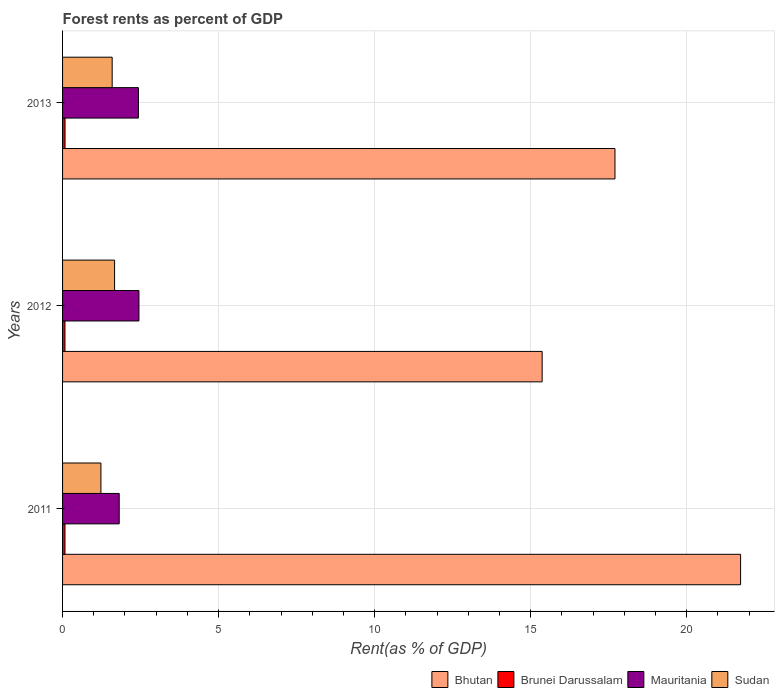How many different coloured bars are there?
Offer a very short reply. 4. Are the number of bars per tick equal to the number of legend labels?
Ensure brevity in your answer.  Yes. How many bars are there on the 1st tick from the top?
Your response must be concise. 4. How many bars are there on the 1st tick from the bottom?
Provide a succinct answer. 4. What is the forest rent in Mauritania in 2013?
Offer a very short reply. 2.43. Across all years, what is the maximum forest rent in Bhutan?
Offer a very short reply. 21.73. Across all years, what is the minimum forest rent in Sudan?
Your answer should be compact. 1.23. What is the total forest rent in Sudan in the graph?
Provide a short and direct response. 4.49. What is the difference between the forest rent in Mauritania in 2011 and that in 2013?
Give a very brief answer. -0.62. What is the difference between the forest rent in Mauritania in 2011 and the forest rent in Brunei Darussalam in 2013?
Make the answer very short. 1.74. What is the average forest rent in Bhutan per year?
Offer a terse response. 18.26. In the year 2012, what is the difference between the forest rent in Sudan and forest rent in Mauritania?
Keep it short and to the point. -0.78. In how many years, is the forest rent in Bhutan greater than 10 %?
Provide a succinct answer. 3. What is the ratio of the forest rent in Sudan in 2011 to that in 2012?
Offer a terse response. 0.74. Is the forest rent in Bhutan in 2011 less than that in 2012?
Provide a short and direct response. No. What is the difference between the highest and the second highest forest rent in Sudan?
Ensure brevity in your answer.  0.08. What is the difference between the highest and the lowest forest rent in Brunei Darussalam?
Provide a succinct answer. 0. In how many years, is the forest rent in Sudan greater than the average forest rent in Sudan taken over all years?
Your response must be concise. 2. What does the 4th bar from the top in 2013 represents?
Offer a very short reply. Bhutan. What does the 2nd bar from the bottom in 2013 represents?
Offer a very short reply. Brunei Darussalam. How many bars are there?
Your response must be concise. 12. How many years are there in the graph?
Give a very brief answer. 3. What is the difference between two consecutive major ticks on the X-axis?
Provide a short and direct response. 5. Does the graph contain any zero values?
Offer a terse response. No. Where does the legend appear in the graph?
Provide a short and direct response. Bottom right. How many legend labels are there?
Your answer should be very brief. 4. How are the legend labels stacked?
Keep it short and to the point. Horizontal. What is the title of the graph?
Your answer should be very brief. Forest rents as percent of GDP. What is the label or title of the X-axis?
Offer a very short reply. Rent(as % of GDP). What is the label or title of the Y-axis?
Offer a terse response. Years. What is the Rent(as % of GDP) in Bhutan in 2011?
Ensure brevity in your answer.  21.73. What is the Rent(as % of GDP) in Brunei Darussalam in 2011?
Your response must be concise. 0.08. What is the Rent(as % of GDP) of Mauritania in 2011?
Your response must be concise. 1.82. What is the Rent(as % of GDP) in Sudan in 2011?
Keep it short and to the point. 1.23. What is the Rent(as % of GDP) of Bhutan in 2012?
Your answer should be compact. 15.37. What is the Rent(as % of GDP) of Brunei Darussalam in 2012?
Offer a terse response. 0.08. What is the Rent(as % of GDP) in Mauritania in 2012?
Ensure brevity in your answer.  2.45. What is the Rent(as % of GDP) in Sudan in 2012?
Your response must be concise. 1.67. What is the Rent(as % of GDP) in Bhutan in 2013?
Offer a very short reply. 17.7. What is the Rent(as % of GDP) in Brunei Darussalam in 2013?
Your answer should be compact. 0.08. What is the Rent(as % of GDP) of Mauritania in 2013?
Provide a short and direct response. 2.43. What is the Rent(as % of GDP) in Sudan in 2013?
Provide a short and direct response. 1.59. Across all years, what is the maximum Rent(as % of GDP) in Bhutan?
Your response must be concise. 21.73. Across all years, what is the maximum Rent(as % of GDP) of Brunei Darussalam?
Offer a very short reply. 0.08. Across all years, what is the maximum Rent(as % of GDP) of Mauritania?
Your answer should be very brief. 2.45. Across all years, what is the maximum Rent(as % of GDP) in Sudan?
Offer a terse response. 1.67. Across all years, what is the minimum Rent(as % of GDP) in Bhutan?
Provide a succinct answer. 15.37. Across all years, what is the minimum Rent(as % of GDP) of Brunei Darussalam?
Make the answer very short. 0.08. Across all years, what is the minimum Rent(as % of GDP) in Mauritania?
Offer a very short reply. 1.82. Across all years, what is the minimum Rent(as % of GDP) in Sudan?
Your answer should be compact. 1.23. What is the total Rent(as % of GDP) of Bhutan in the graph?
Give a very brief answer. 54.79. What is the total Rent(as % of GDP) in Brunei Darussalam in the graph?
Provide a succinct answer. 0.23. What is the total Rent(as % of GDP) in Mauritania in the graph?
Provide a succinct answer. 6.69. What is the total Rent(as % of GDP) in Sudan in the graph?
Your answer should be very brief. 4.49. What is the difference between the Rent(as % of GDP) in Bhutan in 2011 and that in 2012?
Your answer should be compact. 6.36. What is the difference between the Rent(as % of GDP) of Brunei Darussalam in 2011 and that in 2012?
Provide a short and direct response. 0. What is the difference between the Rent(as % of GDP) of Mauritania in 2011 and that in 2012?
Ensure brevity in your answer.  -0.63. What is the difference between the Rent(as % of GDP) of Sudan in 2011 and that in 2012?
Make the answer very short. -0.44. What is the difference between the Rent(as % of GDP) in Bhutan in 2011 and that in 2013?
Your answer should be compact. 4.03. What is the difference between the Rent(as % of GDP) of Brunei Darussalam in 2011 and that in 2013?
Offer a terse response. -0. What is the difference between the Rent(as % of GDP) in Mauritania in 2011 and that in 2013?
Keep it short and to the point. -0.62. What is the difference between the Rent(as % of GDP) of Sudan in 2011 and that in 2013?
Make the answer very short. -0.36. What is the difference between the Rent(as % of GDP) in Bhutan in 2012 and that in 2013?
Your answer should be very brief. -2.33. What is the difference between the Rent(as % of GDP) of Brunei Darussalam in 2012 and that in 2013?
Give a very brief answer. -0. What is the difference between the Rent(as % of GDP) of Mauritania in 2012 and that in 2013?
Keep it short and to the point. 0.02. What is the difference between the Rent(as % of GDP) of Sudan in 2012 and that in 2013?
Your answer should be compact. 0.08. What is the difference between the Rent(as % of GDP) in Bhutan in 2011 and the Rent(as % of GDP) in Brunei Darussalam in 2012?
Offer a very short reply. 21.65. What is the difference between the Rent(as % of GDP) of Bhutan in 2011 and the Rent(as % of GDP) of Mauritania in 2012?
Make the answer very short. 19.28. What is the difference between the Rent(as % of GDP) in Bhutan in 2011 and the Rent(as % of GDP) in Sudan in 2012?
Your answer should be very brief. 20.06. What is the difference between the Rent(as % of GDP) in Brunei Darussalam in 2011 and the Rent(as % of GDP) in Mauritania in 2012?
Give a very brief answer. -2.37. What is the difference between the Rent(as % of GDP) in Brunei Darussalam in 2011 and the Rent(as % of GDP) in Sudan in 2012?
Your answer should be compact. -1.59. What is the difference between the Rent(as % of GDP) of Mauritania in 2011 and the Rent(as % of GDP) of Sudan in 2012?
Your response must be concise. 0.15. What is the difference between the Rent(as % of GDP) in Bhutan in 2011 and the Rent(as % of GDP) in Brunei Darussalam in 2013?
Give a very brief answer. 21.65. What is the difference between the Rent(as % of GDP) in Bhutan in 2011 and the Rent(as % of GDP) in Mauritania in 2013?
Your answer should be compact. 19.3. What is the difference between the Rent(as % of GDP) of Bhutan in 2011 and the Rent(as % of GDP) of Sudan in 2013?
Ensure brevity in your answer.  20.14. What is the difference between the Rent(as % of GDP) of Brunei Darussalam in 2011 and the Rent(as % of GDP) of Mauritania in 2013?
Provide a short and direct response. -2.35. What is the difference between the Rent(as % of GDP) in Brunei Darussalam in 2011 and the Rent(as % of GDP) in Sudan in 2013?
Your answer should be very brief. -1.51. What is the difference between the Rent(as % of GDP) of Mauritania in 2011 and the Rent(as % of GDP) of Sudan in 2013?
Your answer should be very brief. 0.23. What is the difference between the Rent(as % of GDP) of Bhutan in 2012 and the Rent(as % of GDP) of Brunei Darussalam in 2013?
Provide a short and direct response. 15.29. What is the difference between the Rent(as % of GDP) of Bhutan in 2012 and the Rent(as % of GDP) of Mauritania in 2013?
Provide a short and direct response. 12.94. What is the difference between the Rent(as % of GDP) in Bhutan in 2012 and the Rent(as % of GDP) in Sudan in 2013?
Your answer should be compact. 13.78. What is the difference between the Rent(as % of GDP) in Brunei Darussalam in 2012 and the Rent(as % of GDP) in Mauritania in 2013?
Make the answer very short. -2.35. What is the difference between the Rent(as % of GDP) in Brunei Darussalam in 2012 and the Rent(as % of GDP) in Sudan in 2013?
Your answer should be compact. -1.51. What is the difference between the Rent(as % of GDP) of Mauritania in 2012 and the Rent(as % of GDP) of Sudan in 2013?
Make the answer very short. 0.86. What is the average Rent(as % of GDP) of Bhutan per year?
Make the answer very short. 18.26. What is the average Rent(as % of GDP) in Brunei Darussalam per year?
Your response must be concise. 0.08. What is the average Rent(as % of GDP) in Mauritania per year?
Give a very brief answer. 2.23. What is the average Rent(as % of GDP) in Sudan per year?
Offer a very short reply. 1.5. In the year 2011, what is the difference between the Rent(as % of GDP) in Bhutan and Rent(as % of GDP) in Brunei Darussalam?
Offer a terse response. 21.65. In the year 2011, what is the difference between the Rent(as % of GDP) in Bhutan and Rent(as % of GDP) in Mauritania?
Your response must be concise. 19.91. In the year 2011, what is the difference between the Rent(as % of GDP) in Bhutan and Rent(as % of GDP) in Sudan?
Keep it short and to the point. 20.5. In the year 2011, what is the difference between the Rent(as % of GDP) of Brunei Darussalam and Rent(as % of GDP) of Mauritania?
Ensure brevity in your answer.  -1.74. In the year 2011, what is the difference between the Rent(as % of GDP) in Brunei Darussalam and Rent(as % of GDP) in Sudan?
Give a very brief answer. -1.15. In the year 2011, what is the difference between the Rent(as % of GDP) in Mauritania and Rent(as % of GDP) in Sudan?
Offer a terse response. 0.59. In the year 2012, what is the difference between the Rent(as % of GDP) in Bhutan and Rent(as % of GDP) in Brunei Darussalam?
Keep it short and to the point. 15.29. In the year 2012, what is the difference between the Rent(as % of GDP) of Bhutan and Rent(as % of GDP) of Mauritania?
Provide a short and direct response. 12.92. In the year 2012, what is the difference between the Rent(as % of GDP) of Bhutan and Rent(as % of GDP) of Sudan?
Ensure brevity in your answer.  13.7. In the year 2012, what is the difference between the Rent(as % of GDP) of Brunei Darussalam and Rent(as % of GDP) of Mauritania?
Ensure brevity in your answer.  -2.37. In the year 2012, what is the difference between the Rent(as % of GDP) of Brunei Darussalam and Rent(as % of GDP) of Sudan?
Make the answer very short. -1.59. In the year 2012, what is the difference between the Rent(as % of GDP) in Mauritania and Rent(as % of GDP) in Sudan?
Give a very brief answer. 0.78. In the year 2013, what is the difference between the Rent(as % of GDP) in Bhutan and Rent(as % of GDP) in Brunei Darussalam?
Provide a succinct answer. 17.62. In the year 2013, what is the difference between the Rent(as % of GDP) of Bhutan and Rent(as % of GDP) of Mauritania?
Your response must be concise. 15.27. In the year 2013, what is the difference between the Rent(as % of GDP) of Bhutan and Rent(as % of GDP) of Sudan?
Give a very brief answer. 16.11. In the year 2013, what is the difference between the Rent(as % of GDP) in Brunei Darussalam and Rent(as % of GDP) in Mauritania?
Your response must be concise. -2.35. In the year 2013, what is the difference between the Rent(as % of GDP) of Brunei Darussalam and Rent(as % of GDP) of Sudan?
Make the answer very short. -1.51. In the year 2013, what is the difference between the Rent(as % of GDP) of Mauritania and Rent(as % of GDP) of Sudan?
Ensure brevity in your answer.  0.84. What is the ratio of the Rent(as % of GDP) of Bhutan in 2011 to that in 2012?
Keep it short and to the point. 1.41. What is the ratio of the Rent(as % of GDP) in Mauritania in 2011 to that in 2012?
Your response must be concise. 0.74. What is the ratio of the Rent(as % of GDP) of Sudan in 2011 to that in 2012?
Your answer should be compact. 0.74. What is the ratio of the Rent(as % of GDP) of Bhutan in 2011 to that in 2013?
Your response must be concise. 1.23. What is the ratio of the Rent(as % of GDP) in Brunei Darussalam in 2011 to that in 2013?
Provide a succinct answer. 0.98. What is the ratio of the Rent(as % of GDP) of Mauritania in 2011 to that in 2013?
Give a very brief answer. 0.75. What is the ratio of the Rent(as % of GDP) of Sudan in 2011 to that in 2013?
Offer a terse response. 0.77. What is the ratio of the Rent(as % of GDP) in Bhutan in 2012 to that in 2013?
Provide a short and direct response. 0.87. What is the ratio of the Rent(as % of GDP) in Brunei Darussalam in 2012 to that in 2013?
Ensure brevity in your answer.  0.97. What is the ratio of the Rent(as % of GDP) of Mauritania in 2012 to that in 2013?
Provide a short and direct response. 1.01. What is the ratio of the Rent(as % of GDP) of Sudan in 2012 to that in 2013?
Offer a very short reply. 1.05. What is the difference between the highest and the second highest Rent(as % of GDP) in Bhutan?
Offer a terse response. 4.03. What is the difference between the highest and the second highest Rent(as % of GDP) in Brunei Darussalam?
Keep it short and to the point. 0. What is the difference between the highest and the second highest Rent(as % of GDP) in Mauritania?
Your answer should be very brief. 0.02. What is the difference between the highest and the second highest Rent(as % of GDP) of Sudan?
Make the answer very short. 0.08. What is the difference between the highest and the lowest Rent(as % of GDP) in Bhutan?
Ensure brevity in your answer.  6.36. What is the difference between the highest and the lowest Rent(as % of GDP) of Brunei Darussalam?
Offer a terse response. 0. What is the difference between the highest and the lowest Rent(as % of GDP) of Mauritania?
Offer a very short reply. 0.63. What is the difference between the highest and the lowest Rent(as % of GDP) in Sudan?
Provide a short and direct response. 0.44. 